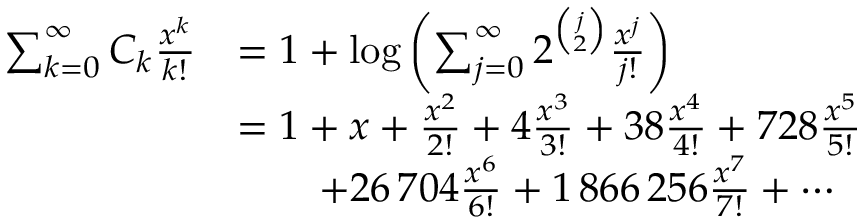Convert formula to latex. <formula><loc_0><loc_0><loc_500><loc_500>\begin{array} { r l } { \sum _ { k = 0 } ^ { \infty } C _ { k } \frac { x ^ { k } } { k ! } } & { = 1 + \log \left ( \sum _ { j = 0 } ^ { \infty } 2 ^ { \binom { j } { 2 } } \frac { x ^ { j } } { j ! } \right ) } \\ & { = 1 + x + \frac { x ^ { 2 } } { 2 ! } + 4 \frac { x ^ { 3 } } { 3 ! } + 3 8 \frac { x ^ { 4 } } { 4 ! } + 7 2 8 \frac { x ^ { 5 } } { 5 ! } } \\ & { \quad + 2 6 \, 7 0 4 \frac { x ^ { 6 } } { 6 ! } + 1 \, 8 6 6 \, 2 5 6 \frac { x ^ { 7 } } { 7 ! } + \cdots } \end{array}</formula> 